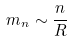<formula> <loc_0><loc_0><loc_500><loc_500>m _ { n } \sim \frac { n } { R }</formula> 